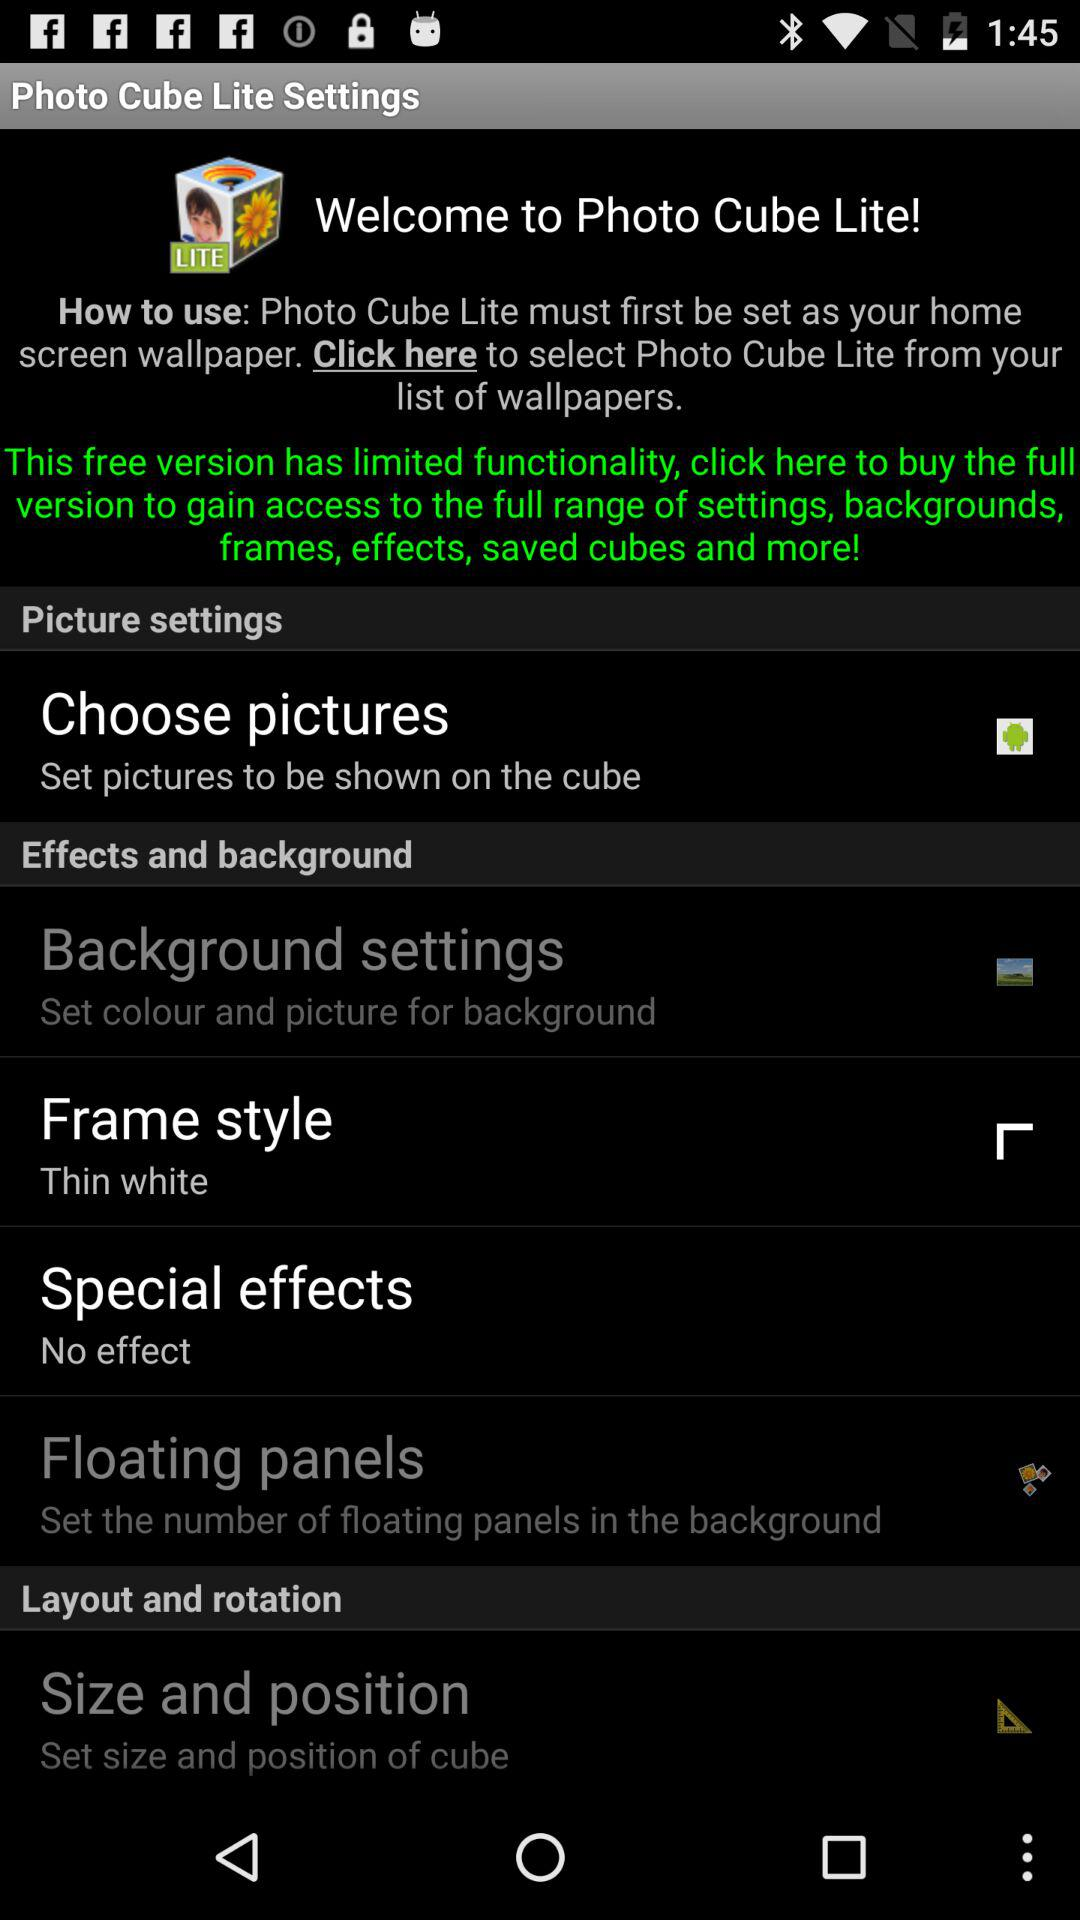How many items are in the settings menu?
Answer the question using a single word or phrase. 6 